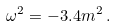<formula> <loc_0><loc_0><loc_500><loc_500>\omega ^ { 2 } = - 3 . 4 m ^ { 2 } \, .</formula> 